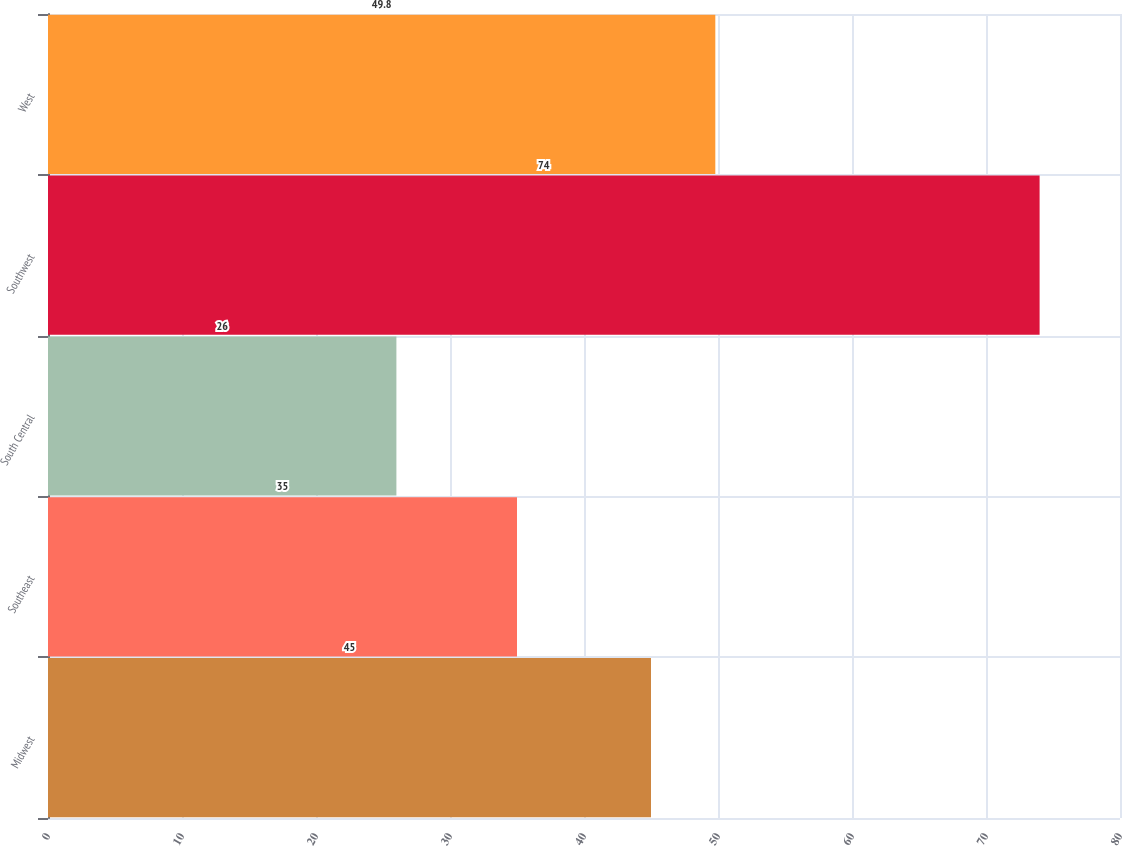Convert chart to OTSL. <chart><loc_0><loc_0><loc_500><loc_500><bar_chart><fcel>Midwest<fcel>Southeast<fcel>South Central<fcel>Southwest<fcel>West<nl><fcel>45<fcel>35<fcel>26<fcel>74<fcel>49.8<nl></chart> 